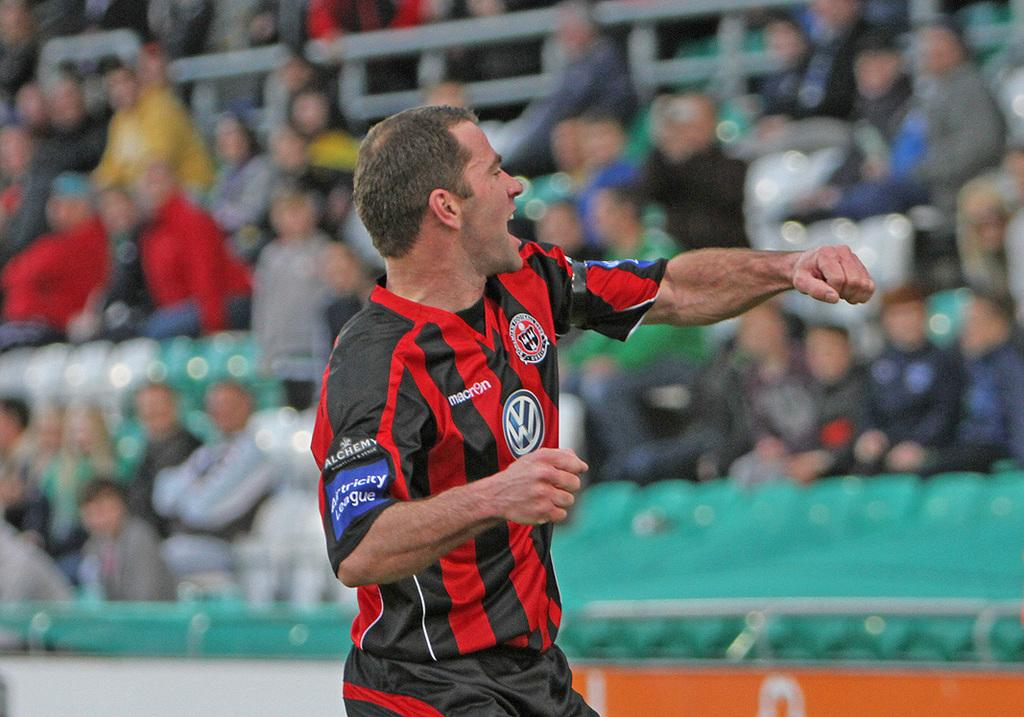<image>
Describe the image concisely. A red and black soccer shirt and the volkswagen logo is being worn by a man. 